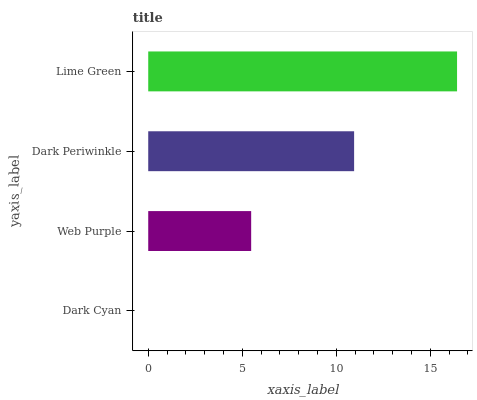Is Dark Cyan the minimum?
Answer yes or no. Yes. Is Lime Green the maximum?
Answer yes or no. Yes. Is Web Purple the minimum?
Answer yes or no. No. Is Web Purple the maximum?
Answer yes or no. No. Is Web Purple greater than Dark Cyan?
Answer yes or no. Yes. Is Dark Cyan less than Web Purple?
Answer yes or no. Yes. Is Dark Cyan greater than Web Purple?
Answer yes or no. No. Is Web Purple less than Dark Cyan?
Answer yes or no. No. Is Dark Periwinkle the high median?
Answer yes or no. Yes. Is Web Purple the low median?
Answer yes or no. Yes. Is Lime Green the high median?
Answer yes or no. No. Is Lime Green the low median?
Answer yes or no. No. 